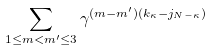Convert formula to latex. <formula><loc_0><loc_0><loc_500><loc_500>\sum _ { 1 \leq m < m ^ { \prime } \leq 3 } \gamma ^ { ( m - m ^ { \prime } ) ( k _ { \kappa } - j _ { N - \kappa } ) }</formula> 